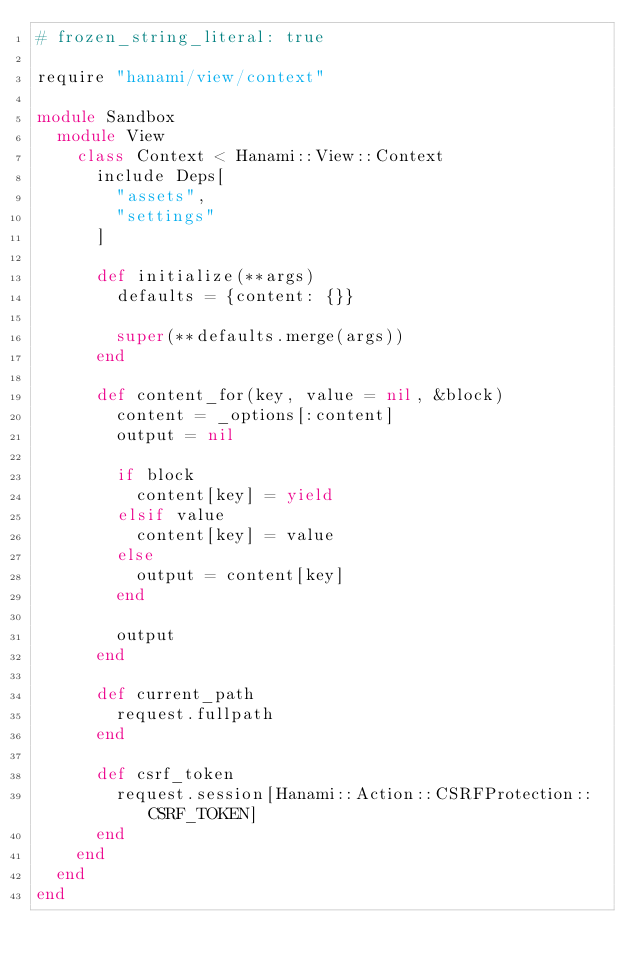<code> <loc_0><loc_0><loc_500><loc_500><_Ruby_># frozen_string_literal: true

require "hanami/view/context"

module Sandbox
  module View
    class Context < Hanami::View::Context
      include Deps[
        "assets",
        "settings"
      ]

      def initialize(**args)
        defaults = {content: {}}

        super(**defaults.merge(args))
      end

      def content_for(key, value = nil, &block)
        content = _options[:content]
        output = nil

        if block
          content[key] = yield
        elsif value
          content[key] = value
        else
          output = content[key]
        end

        output
      end

      def current_path
        request.fullpath
      end

      def csrf_token
        request.session[Hanami::Action::CSRFProtection::CSRF_TOKEN]
      end
    end
  end
end
</code> 